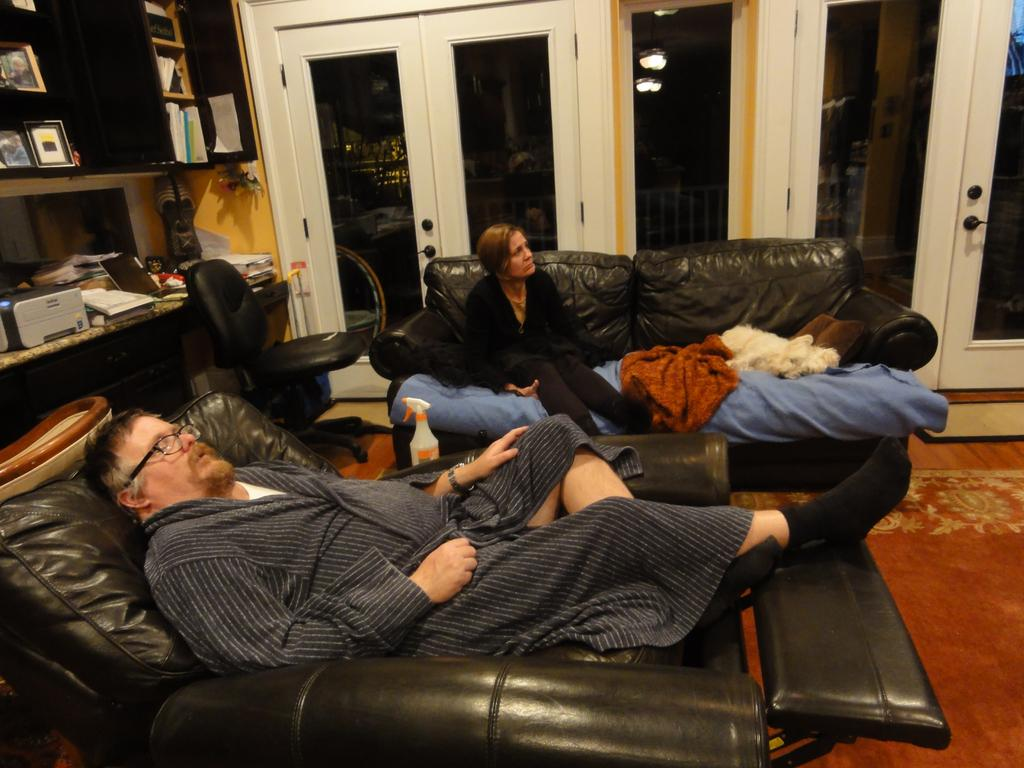How many people are in the image? There are two people in the image, a man and a woman. What are the man and woman doing in the image? Both the man and woman are lying on a couch. What objects can be seen in the image besides the couch in the image? There is a printer, a chair, a door, and a carpeted floor visible in the image. What type of insurance policy is the man discussing with the woman in the image? There is no indication in the image that the man and woman are discussing insurance or any other topic; they are simply lying on a couch. 